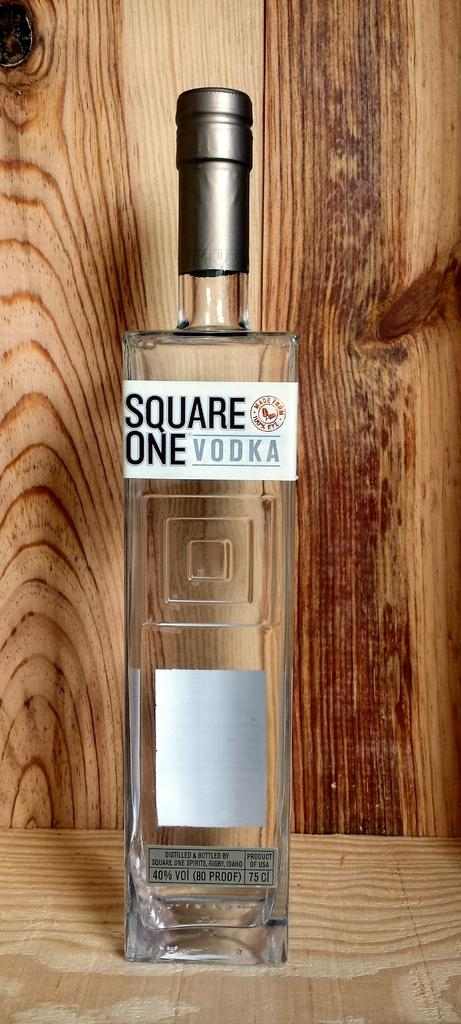<image>
Provide a brief description of the given image. A clear bottle of square one vodka with a wooden background. 